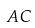Convert formula to latex. <formula><loc_0><loc_0><loc_500><loc_500>A C</formula> 